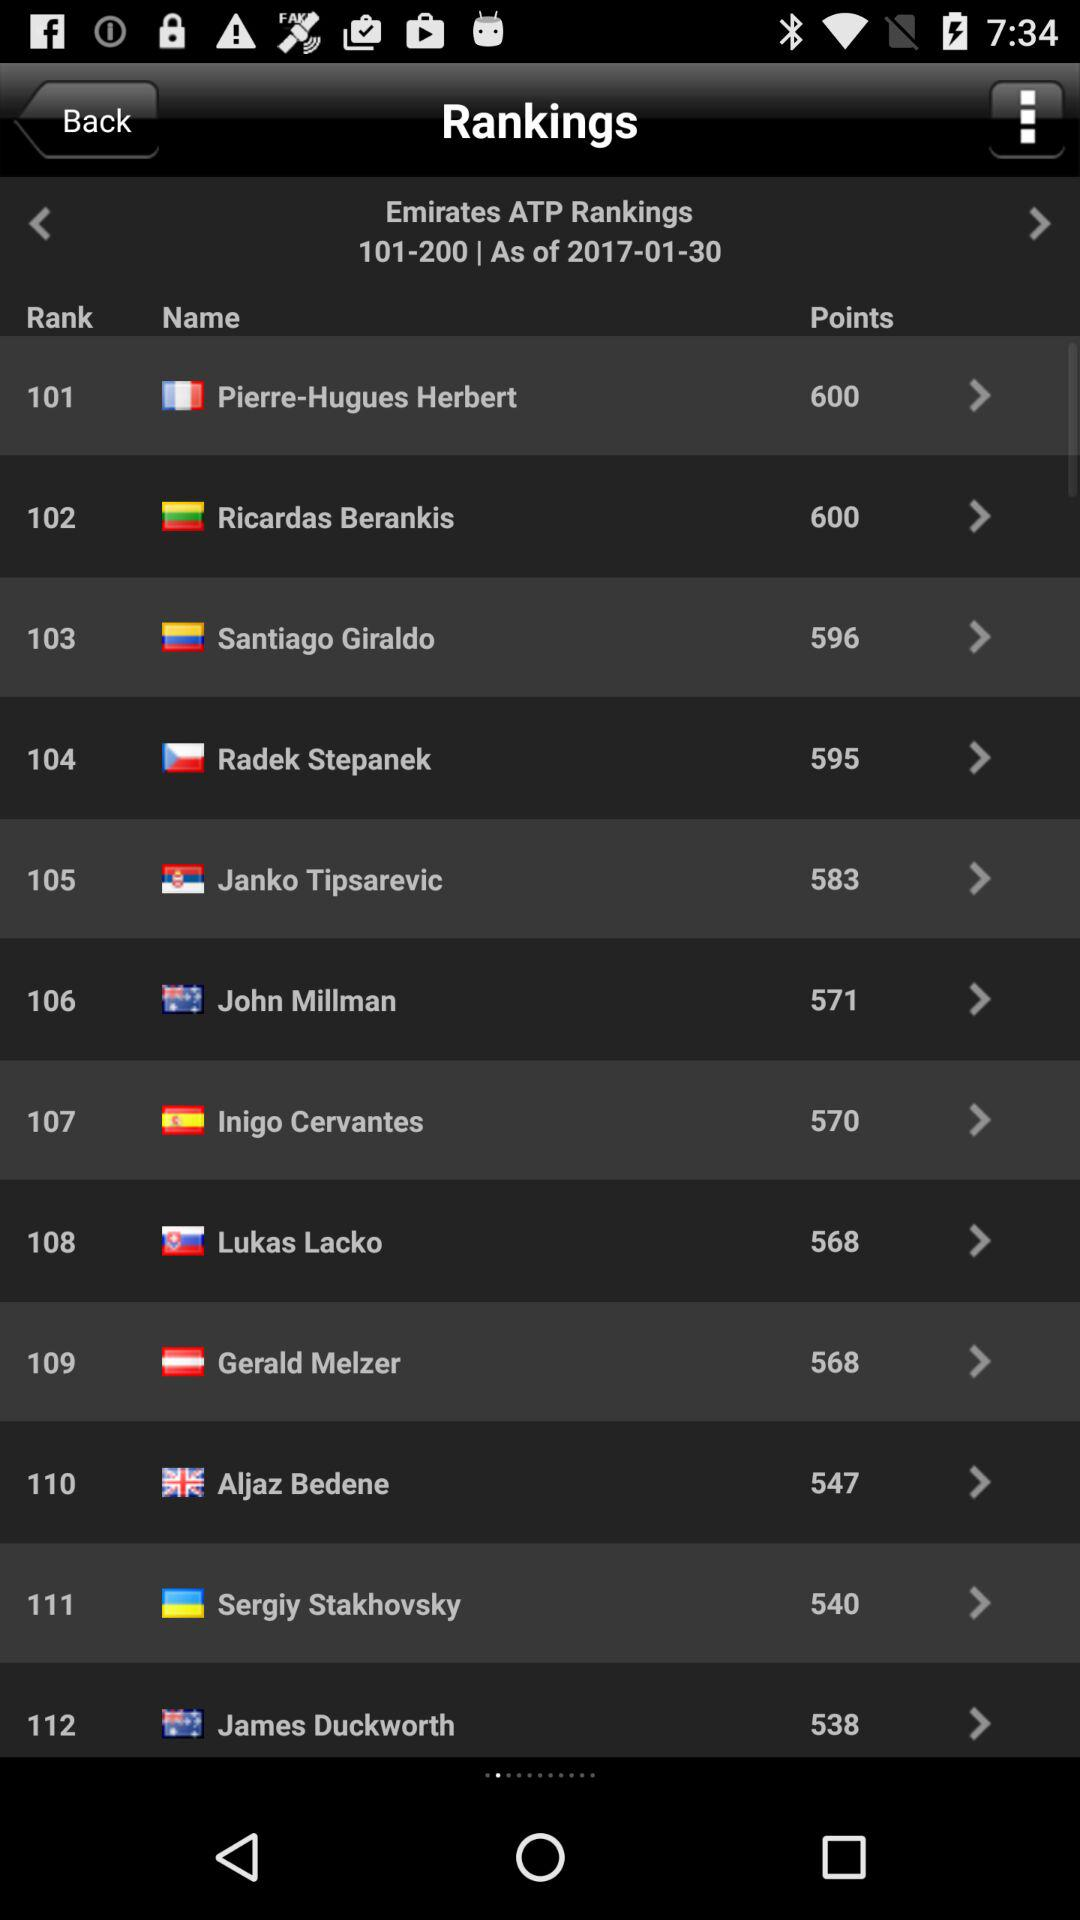Which player has the rank of 104? The player with the rank of 104 is Radek Stepanek. 